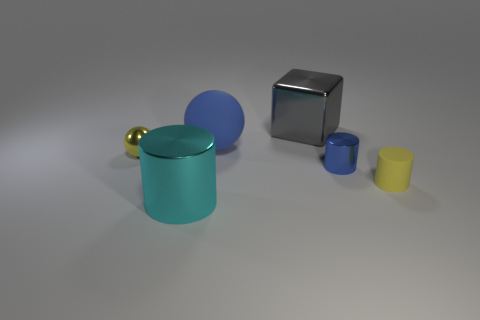Is the number of cylinders that are to the right of the cyan object the same as the number of blue rubber things behind the tiny yellow cylinder?
Offer a terse response. No. Is there another cyan thing that has the same size as the cyan metal object?
Give a very brief answer. No. What is the size of the gray thing?
Give a very brief answer. Large. Are there the same number of balls behind the gray cube and yellow rubber cylinders?
Ensure brevity in your answer.  No. How many other things are there of the same color as the matte ball?
Make the answer very short. 1. What color is the big object that is both in front of the gray cube and behind the yellow matte cylinder?
Make the answer very short. Blue. There is a matte object that is behind the yellow thing that is in front of the small yellow thing that is on the left side of the big gray object; what size is it?
Your response must be concise. Large. What number of things are blue objects on the right side of the large blue rubber object or rubber things to the right of the gray object?
Offer a terse response. 2. What is the shape of the big cyan shiny object?
Your answer should be compact. Cylinder. What number of other things are made of the same material as the cyan thing?
Provide a short and direct response. 3. 